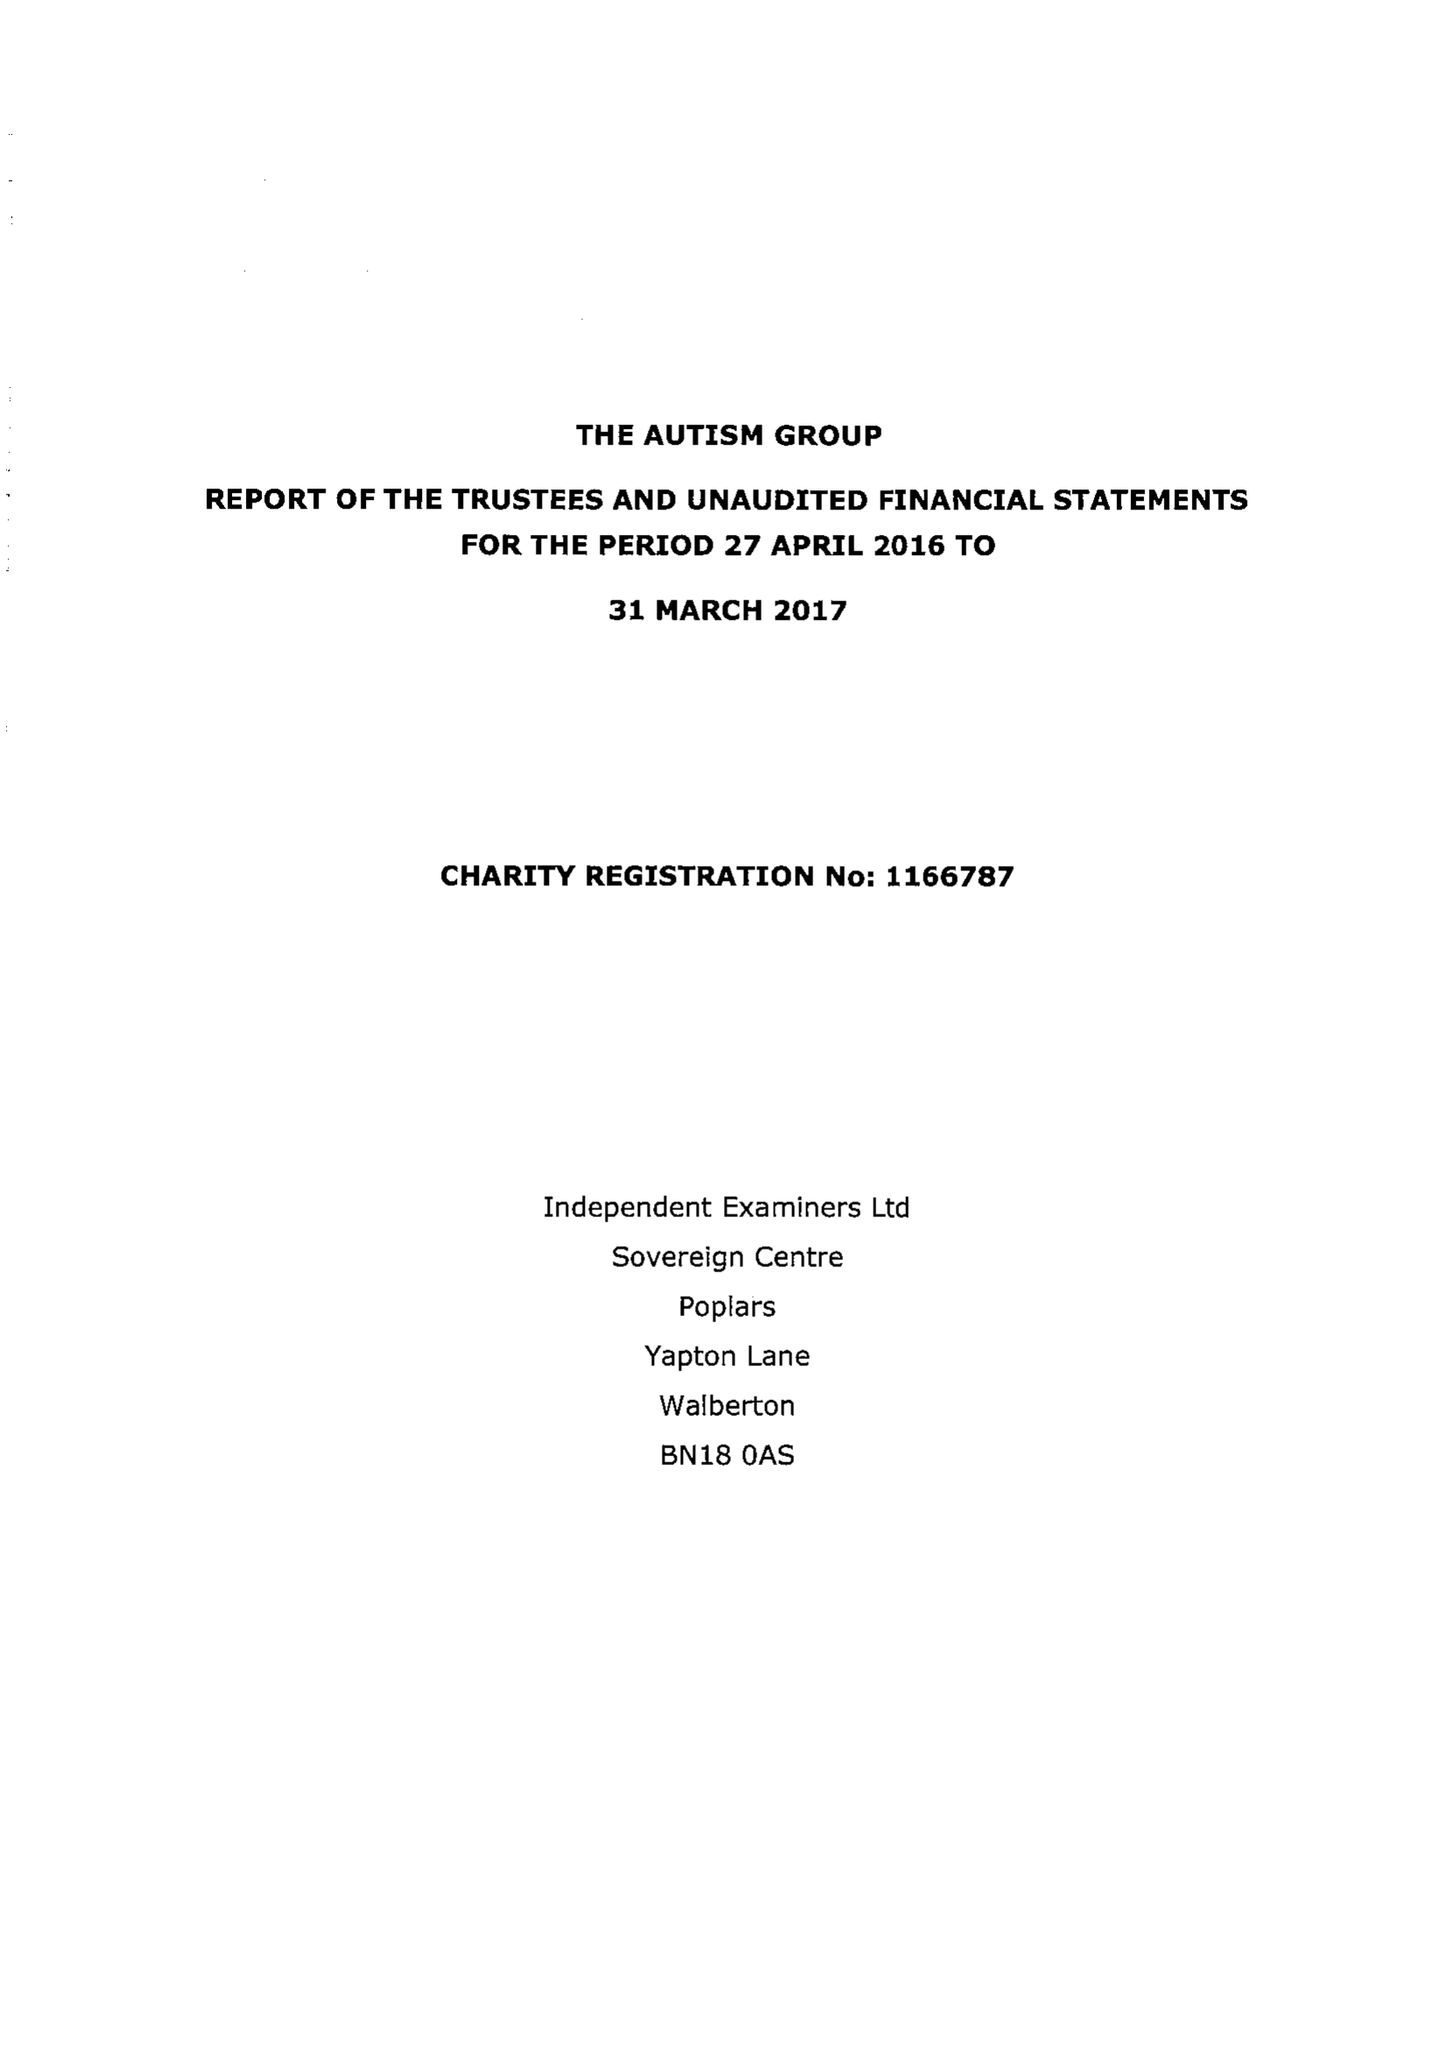What is the value for the address__street_line?
Answer the question using a single word or phrase. 29 BROADWAY 